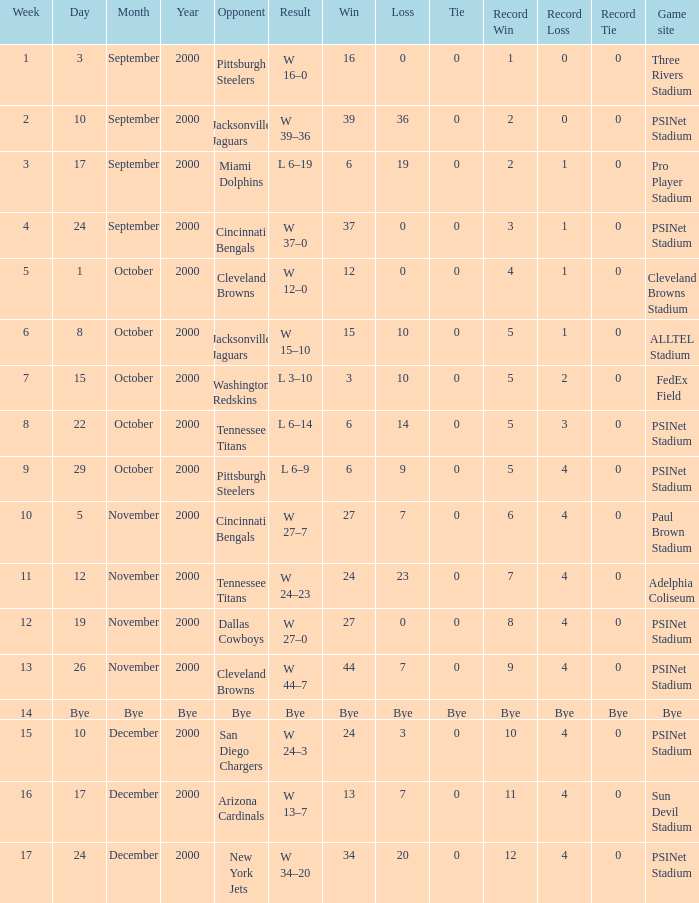Write the full table. {'header': ['Week', 'Day', 'Month', 'Year', 'Opponent', 'Result', 'Win', 'Loss', 'Tie', 'Record Win', 'Record Loss', 'Record Tie', 'Game site'], 'rows': [['1', '3', 'September', '2000', 'Pittsburgh Steelers', 'W 16–0', '16', '0', '0', '1', '0', '0', 'Three Rivers Stadium'], ['2', '10', 'September', '2000', 'Jacksonville Jaguars', 'W 39–36', '39', '36', '0', '2', '0', '0', 'PSINet Stadium'], ['3', '17', 'September', '2000', 'Miami Dolphins', 'L 6–19', '6', '19', '0', '2', '1', '0', 'Pro Player Stadium'], ['4', '24', 'September', '2000', 'Cincinnati Bengals', 'W 37–0', '37', '0', '0', '3', '1', '0', 'PSINet Stadium'], ['5', '1', 'October', '2000', 'Cleveland Browns', 'W 12–0', '12', '0', '0', '4', '1', '0', 'Cleveland Browns Stadium'], ['6', '8', 'October', '2000', 'Jacksonville Jaguars', 'W 15–10', '15', '10', '0', '5', '1', '0', 'ALLTEL Stadium'], ['7', '15', 'October', '2000', 'Washington Redskins', 'L 3–10', '3', '10', '0', '5', '2', '0', 'FedEx Field'], ['8', '22', 'October', '2000', 'Tennessee Titans', 'L 6–14', '6', '14', '0', '5', '3', '0', 'PSINet Stadium'], ['9', '29', 'October', '2000', 'Pittsburgh Steelers', 'L 6–9', '6', '9', '0', '5', '4', '0', 'PSINet Stadium'], ['10', '5', 'November', '2000', 'Cincinnati Bengals', 'W 27–7', '27', '7', '0', '6', '4', '0', 'Paul Brown Stadium'], ['11', '12', 'November', '2000', 'Tennessee Titans', 'W 24–23', '24', '23', '0', '7', '4', '0', 'Adelphia Coliseum'], ['12', '19', 'November', '2000', 'Dallas Cowboys', 'W 27–0', '27', '0', '0', '8', '4', '0', 'PSINet Stadium'], ['13', '26', 'November', '2000', 'Cleveland Browns', 'W 44–7', '44', '7', '0', '9', '4', '0', 'PSINet Stadium'], ['14', 'Bye', 'Bye', 'Bye', 'Bye', 'Bye', 'Bye', 'Bye', 'Bye', 'Bye', 'Bye', 'Bye', 'Bye'], ['15', '10', 'December', '2000', 'San Diego Chargers', 'W 24–3', '24', '3', '0', '10', '4', '0', 'PSINet Stadium'], ['16', '17', 'December', '2000', 'Arizona Cardinals', 'W 13–7', '13', '7', '0', '11', '4', '0', 'Sun Devil Stadium'], ['17', '24', 'December', '2000', 'New York Jets', 'W 34–20', '34', '20', '0', '12', '4', '0', 'PSINet Stadium']]} What's the record after week 16? 12–4–0. 